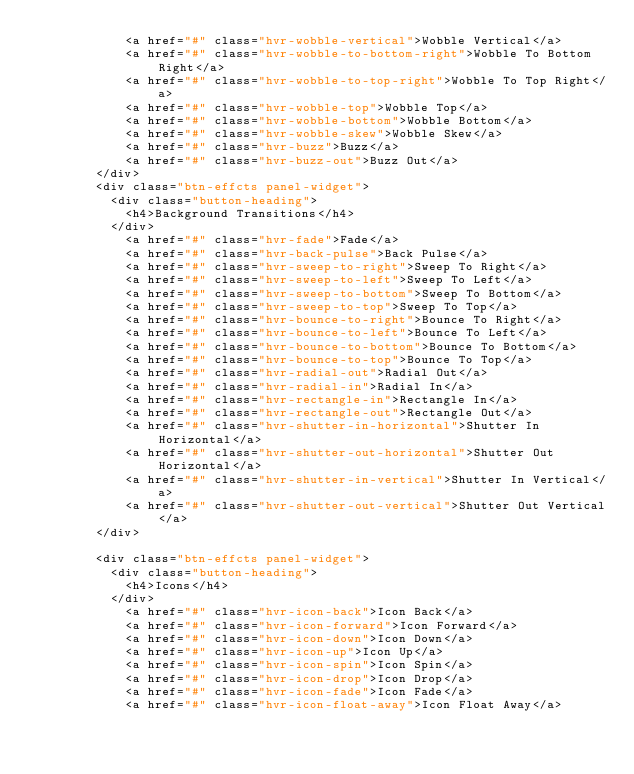<code> <loc_0><loc_0><loc_500><loc_500><_PHP_>						<a href="#" class="hvr-wobble-vertical">Wobble Vertical</a>
						<a href="#" class="hvr-wobble-to-bottom-right">Wobble To Bottom Right</a>
						<a href="#" class="hvr-wobble-to-top-right">Wobble To Top Right</a>
						<a href="#" class="hvr-wobble-top">Wobble Top</a>
						<a href="#" class="hvr-wobble-bottom">Wobble Bottom</a>
						<a href="#" class="hvr-wobble-skew">Wobble Skew</a>
						<a href="#" class="hvr-buzz">Buzz</a>
						<a href="#" class="hvr-buzz-out">Buzz Out</a>
				</div>	
				<div class="btn-effcts panel-widget">
					<div class="button-heading">
						<h4>Background Transitions</h4>
					</div>
						<a href="#" class="hvr-fade">Fade</a>
						<a href="#" class="hvr-back-pulse">Back Pulse</a>
						<a href="#" class="hvr-sweep-to-right">Sweep To Right</a>
						<a href="#" class="hvr-sweep-to-left">Sweep To Left</a>
						<a href="#" class="hvr-sweep-to-bottom">Sweep To Bottom</a>
						<a href="#" class="hvr-sweep-to-top">Sweep To Top</a>
						<a href="#" class="hvr-bounce-to-right">Bounce To Right</a>
						<a href="#" class="hvr-bounce-to-left">Bounce To Left</a>
						<a href="#" class="hvr-bounce-to-bottom">Bounce To Bottom</a>
						<a href="#" class="hvr-bounce-to-top">Bounce To Top</a>
						<a href="#" class="hvr-radial-out">Radial Out</a>
						<a href="#" class="hvr-radial-in">Radial In</a>
						<a href="#" class="hvr-rectangle-in">Rectangle In</a>
						<a href="#" class="hvr-rectangle-out">Rectangle Out</a>
						<a href="#" class="hvr-shutter-in-horizontal">Shutter In Horizontal</a>
						<a href="#" class="hvr-shutter-out-horizontal">Shutter Out Horizontal</a>
						<a href="#" class="hvr-shutter-in-vertical">Shutter In Vertical</a>
						<a href="#" class="hvr-shutter-out-vertical">Shutter Out Vertical</a>	
				</div>
				
				<div class="btn-effcts panel-widget">
					<div class="button-heading">
						<h4>Icons</h4>
					</div>
						<a href="#" class="hvr-icon-back">Icon Back</a>
						<a href="#" class="hvr-icon-forward">Icon Forward</a>
						<a href="#" class="hvr-icon-down">Icon Down</a>
						<a href="#" class="hvr-icon-up">Icon Up</a>
						<a href="#" class="hvr-icon-spin">Icon Spin</a>
						<a href="#" class="hvr-icon-drop">Icon Drop</a>
						<a href="#" class="hvr-icon-fade">Icon Fade</a>
						<a href="#" class="hvr-icon-float-away">Icon Float Away</a></code> 